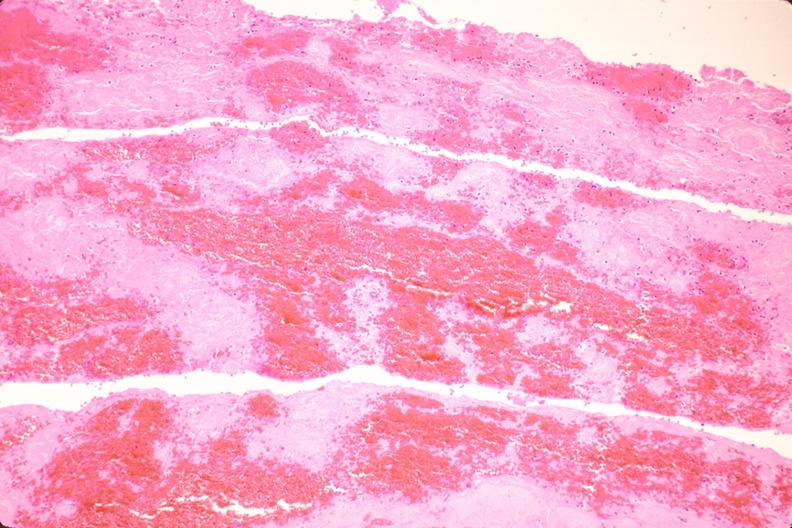s acid present?
Answer the question using a single word or phrase. No 